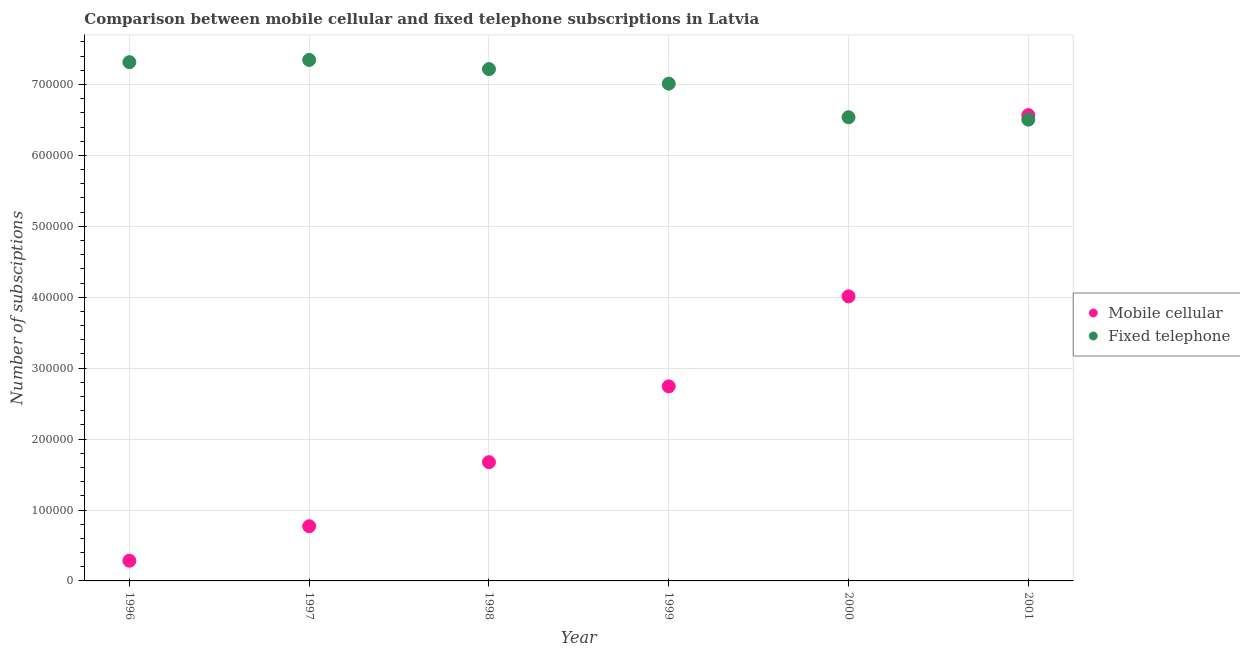What is the number of fixed telephone subscriptions in 1999?
Your response must be concise. 7.01e+05. Across all years, what is the maximum number of mobile cellular subscriptions?
Your response must be concise. 6.57e+05. Across all years, what is the minimum number of mobile cellular subscriptions?
Provide a short and direct response. 2.85e+04. In which year was the number of mobile cellular subscriptions maximum?
Your answer should be very brief. 2001. In which year was the number of mobile cellular subscriptions minimum?
Provide a succinct answer. 1996. What is the total number of fixed telephone subscriptions in the graph?
Your answer should be very brief. 4.19e+06. What is the difference between the number of fixed telephone subscriptions in 1998 and that in 2001?
Your answer should be very brief. 7.13e+04. What is the difference between the number of mobile cellular subscriptions in 1996 and the number of fixed telephone subscriptions in 1998?
Provide a short and direct response. -6.93e+05. What is the average number of fixed telephone subscriptions per year?
Your answer should be very brief. 6.99e+05. In the year 2001, what is the difference between the number of mobile cellular subscriptions and number of fixed telephone subscriptions?
Keep it short and to the point. 6380. What is the ratio of the number of mobile cellular subscriptions in 1996 to that in 1997?
Ensure brevity in your answer.  0.37. What is the difference between the highest and the second highest number of mobile cellular subscriptions?
Provide a short and direct response. 2.56e+05. What is the difference between the highest and the lowest number of mobile cellular subscriptions?
Ensure brevity in your answer.  6.28e+05. In how many years, is the number of mobile cellular subscriptions greater than the average number of mobile cellular subscriptions taken over all years?
Your response must be concise. 3. Is the number of mobile cellular subscriptions strictly less than the number of fixed telephone subscriptions over the years?
Give a very brief answer. No. What is the difference between two consecutive major ticks on the Y-axis?
Provide a succinct answer. 1.00e+05. Are the values on the major ticks of Y-axis written in scientific E-notation?
Offer a terse response. No. Where does the legend appear in the graph?
Offer a terse response. Center right. How many legend labels are there?
Give a very brief answer. 2. What is the title of the graph?
Provide a succinct answer. Comparison between mobile cellular and fixed telephone subscriptions in Latvia. What is the label or title of the Y-axis?
Your answer should be very brief. Number of subsciptions. What is the Number of subsciptions of Mobile cellular in 1996?
Provide a succinct answer. 2.85e+04. What is the Number of subsciptions of Fixed telephone in 1996?
Make the answer very short. 7.32e+05. What is the Number of subsciptions of Mobile cellular in 1997?
Your answer should be compact. 7.71e+04. What is the Number of subsciptions in Fixed telephone in 1997?
Provide a succinct answer. 7.35e+05. What is the Number of subsciptions of Mobile cellular in 1998?
Provide a succinct answer. 1.67e+05. What is the Number of subsciptions of Fixed telephone in 1998?
Offer a terse response. 7.22e+05. What is the Number of subsciptions of Mobile cellular in 1999?
Ensure brevity in your answer.  2.74e+05. What is the Number of subsciptions in Fixed telephone in 1999?
Your answer should be compact. 7.01e+05. What is the Number of subsciptions of Mobile cellular in 2000?
Give a very brief answer. 4.01e+05. What is the Number of subsciptions in Fixed telephone in 2000?
Provide a succinct answer. 6.54e+05. What is the Number of subsciptions of Mobile cellular in 2001?
Keep it short and to the point. 6.57e+05. What is the Number of subsciptions of Fixed telephone in 2001?
Give a very brief answer. 6.50e+05. Across all years, what is the maximum Number of subsciptions in Mobile cellular?
Provide a succinct answer. 6.57e+05. Across all years, what is the maximum Number of subsciptions in Fixed telephone?
Keep it short and to the point. 7.35e+05. Across all years, what is the minimum Number of subsciptions of Mobile cellular?
Your response must be concise. 2.85e+04. Across all years, what is the minimum Number of subsciptions of Fixed telephone?
Your answer should be very brief. 6.50e+05. What is the total Number of subsciptions in Mobile cellular in the graph?
Give a very brief answer. 1.61e+06. What is the total Number of subsciptions in Fixed telephone in the graph?
Provide a succinct answer. 4.19e+06. What is the difference between the Number of subsciptions in Mobile cellular in 1996 and that in 1997?
Offer a very short reply. -4.86e+04. What is the difference between the Number of subsciptions of Fixed telephone in 1996 and that in 1997?
Ensure brevity in your answer.  -3166. What is the difference between the Number of subsciptions of Mobile cellular in 1996 and that in 1998?
Offer a very short reply. -1.39e+05. What is the difference between the Number of subsciptions in Fixed telephone in 1996 and that in 1998?
Your response must be concise. 9775. What is the difference between the Number of subsciptions in Mobile cellular in 1996 and that in 1999?
Your answer should be compact. -2.46e+05. What is the difference between the Number of subsciptions of Fixed telephone in 1996 and that in 1999?
Provide a short and direct response. 3.03e+04. What is the difference between the Number of subsciptions in Mobile cellular in 1996 and that in 2000?
Ensure brevity in your answer.  -3.73e+05. What is the difference between the Number of subsciptions in Fixed telephone in 1996 and that in 2000?
Your answer should be very brief. 7.77e+04. What is the difference between the Number of subsciptions of Mobile cellular in 1996 and that in 2001?
Give a very brief answer. -6.28e+05. What is the difference between the Number of subsciptions in Fixed telephone in 1996 and that in 2001?
Your answer should be very brief. 8.11e+04. What is the difference between the Number of subsciptions of Mobile cellular in 1997 and that in 1998?
Provide a succinct answer. -9.04e+04. What is the difference between the Number of subsciptions in Fixed telephone in 1997 and that in 1998?
Make the answer very short. 1.29e+04. What is the difference between the Number of subsciptions in Mobile cellular in 1997 and that in 1999?
Ensure brevity in your answer.  -1.97e+05. What is the difference between the Number of subsciptions of Fixed telephone in 1997 and that in 1999?
Keep it short and to the point. 3.35e+04. What is the difference between the Number of subsciptions of Mobile cellular in 1997 and that in 2000?
Offer a terse response. -3.24e+05. What is the difference between the Number of subsciptions of Fixed telephone in 1997 and that in 2000?
Offer a very short reply. 8.08e+04. What is the difference between the Number of subsciptions of Mobile cellular in 1997 and that in 2001?
Offer a very short reply. -5.80e+05. What is the difference between the Number of subsciptions of Fixed telephone in 1997 and that in 2001?
Provide a succinct answer. 8.42e+04. What is the difference between the Number of subsciptions of Mobile cellular in 1998 and that in 1999?
Give a very brief answer. -1.07e+05. What is the difference between the Number of subsciptions in Fixed telephone in 1998 and that in 1999?
Keep it short and to the point. 2.05e+04. What is the difference between the Number of subsciptions in Mobile cellular in 1998 and that in 2000?
Your answer should be very brief. -2.34e+05. What is the difference between the Number of subsciptions in Fixed telephone in 1998 and that in 2000?
Your answer should be very brief. 6.79e+04. What is the difference between the Number of subsciptions of Mobile cellular in 1998 and that in 2001?
Your response must be concise. -4.89e+05. What is the difference between the Number of subsciptions of Fixed telephone in 1998 and that in 2001?
Keep it short and to the point. 7.13e+04. What is the difference between the Number of subsciptions in Mobile cellular in 1999 and that in 2000?
Ensure brevity in your answer.  -1.27e+05. What is the difference between the Number of subsciptions in Fixed telephone in 1999 and that in 2000?
Provide a succinct answer. 4.74e+04. What is the difference between the Number of subsciptions in Mobile cellular in 1999 and that in 2001?
Your answer should be compact. -3.82e+05. What is the difference between the Number of subsciptions of Fixed telephone in 1999 and that in 2001?
Provide a succinct answer. 5.08e+04. What is the difference between the Number of subsciptions in Mobile cellular in 2000 and that in 2001?
Your answer should be compact. -2.56e+05. What is the difference between the Number of subsciptions of Fixed telephone in 2000 and that in 2001?
Give a very brief answer. 3398. What is the difference between the Number of subsciptions in Mobile cellular in 1996 and the Number of subsciptions in Fixed telephone in 1997?
Provide a succinct answer. -7.06e+05. What is the difference between the Number of subsciptions in Mobile cellular in 1996 and the Number of subsciptions in Fixed telephone in 1998?
Give a very brief answer. -6.93e+05. What is the difference between the Number of subsciptions of Mobile cellular in 1996 and the Number of subsciptions of Fixed telephone in 1999?
Keep it short and to the point. -6.73e+05. What is the difference between the Number of subsciptions in Mobile cellular in 1996 and the Number of subsciptions in Fixed telephone in 2000?
Make the answer very short. -6.25e+05. What is the difference between the Number of subsciptions in Mobile cellular in 1996 and the Number of subsciptions in Fixed telephone in 2001?
Provide a succinct answer. -6.22e+05. What is the difference between the Number of subsciptions in Mobile cellular in 1997 and the Number of subsciptions in Fixed telephone in 1998?
Keep it short and to the point. -6.45e+05. What is the difference between the Number of subsciptions in Mobile cellular in 1997 and the Number of subsciptions in Fixed telephone in 1999?
Provide a short and direct response. -6.24e+05. What is the difference between the Number of subsciptions of Mobile cellular in 1997 and the Number of subsciptions of Fixed telephone in 2000?
Make the answer very short. -5.77e+05. What is the difference between the Number of subsciptions of Mobile cellular in 1997 and the Number of subsciptions of Fixed telephone in 2001?
Make the answer very short. -5.73e+05. What is the difference between the Number of subsciptions in Mobile cellular in 1998 and the Number of subsciptions in Fixed telephone in 1999?
Ensure brevity in your answer.  -5.34e+05. What is the difference between the Number of subsciptions of Mobile cellular in 1998 and the Number of subsciptions of Fixed telephone in 2000?
Your answer should be compact. -4.86e+05. What is the difference between the Number of subsciptions of Mobile cellular in 1998 and the Number of subsciptions of Fixed telephone in 2001?
Ensure brevity in your answer.  -4.83e+05. What is the difference between the Number of subsciptions in Mobile cellular in 1999 and the Number of subsciptions in Fixed telephone in 2000?
Provide a short and direct response. -3.80e+05. What is the difference between the Number of subsciptions of Mobile cellular in 1999 and the Number of subsciptions of Fixed telephone in 2001?
Ensure brevity in your answer.  -3.76e+05. What is the difference between the Number of subsciptions in Mobile cellular in 2000 and the Number of subsciptions in Fixed telephone in 2001?
Ensure brevity in your answer.  -2.49e+05. What is the average Number of subsciptions of Mobile cellular per year?
Your answer should be very brief. 2.68e+05. What is the average Number of subsciptions in Fixed telephone per year?
Your response must be concise. 6.99e+05. In the year 1996, what is the difference between the Number of subsciptions in Mobile cellular and Number of subsciptions in Fixed telephone?
Provide a succinct answer. -7.03e+05. In the year 1997, what is the difference between the Number of subsciptions in Mobile cellular and Number of subsciptions in Fixed telephone?
Your response must be concise. -6.58e+05. In the year 1998, what is the difference between the Number of subsciptions in Mobile cellular and Number of subsciptions in Fixed telephone?
Ensure brevity in your answer.  -5.54e+05. In the year 1999, what is the difference between the Number of subsciptions in Mobile cellular and Number of subsciptions in Fixed telephone?
Keep it short and to the point. -4.27e+05. In the year 2000, what is the difference between the Number of subsciptions in Mobile cellular and Number of subsciptions in Fixed telephone?
Offer a terse response. -2.53e+05. In the year 2001, what is the difference between the Number of subsciptions of Mobile cellular and Number of subsciptions of Fixed telephone?
Offer a terse response. 6380. What is the ratio of the Number of subsciptions in Mobile cellular in 1996 to that in 1997?
Your answer should be very brief. 0.37. What is the ratio of the Number of subsciptions in Fixed telephone in 1996 to that in 1997?
Give a very brief answer. 1. What is the ratio of the Number of subsciptions of Mobile cellular in 1996 to that in 1998?
Give a very brief answer. 0.17. What is the ratio of the Number of subsciptions of Fixed telephone in 1996 to that in 1998?
Your answer should be very brief. 1.01. What is the ratio of the Number of subsciptions of Mobile cellular in 1996 to that in 1999?
Provide a short and direct response. 0.1. What is the ratio of the Number of subsciptions of Fixed telephone in 1996 to that in 1999?
Your answer should be very brief. 1.04. What is the ratio of the Number of subsciptions of Mobile cellular in 1996 to that in 2000?
Ensure brevity in your answer.  0.07. What is the ratio of the Number of subsciptions in Fixed telephone in 1996 to that in 2000?
Offer a terse response. 1.12. What is the ratio of the Number of subsciptions in Mobile cellular in 1996 to that in 2001?
Your response must be concise. 0.04. What is the ratio of the Number of subsciptions of Fixed telephone in 1996 to that in 2001?
Offer a very short reply. 1.12. What is the ratio of the Number of subsciptions of Mobile cellular in 1997 to that in 1998?
Your answer should be compact. 0.46. What is the ratio of the Number of subsciptions in Fixed telephone in 1997 to that in 1998?
Offer a very short reply. 1.02. What is the ratio of the Number of subsciptions in Mobile cellular in 1997 to that in 1999?
Ensure brevity in your answer.  0.28. What is the ratio of the Number of subsciptions in Fixed telephone in 1997 to that in 1999?
Offer a terse response. 1.05. What is the ratio of the Number of subsciptions of Mobile cellular in 1997 to that in 2000?
Make the answer very short. 0.19. What is the ratio of the Number of subsciptions of Fixed telephone in 1997 to that in 2000?
Your answer should be compact. 1.12. What is the ratio of the Number of subsciptions in Mobile cellular in 1997 to that in 2001?
Your answer should be very brief. 0.12. What is the ratio of the Number of subsciptions of Fixed telephone in 1997 to that in 2001?
Offer a terse response. 1.13. What is the ratio of the Number of subsciptions in Mobile cellular in 1998 to that in 1999?
Your response must be concise. 0.61. What is the ratio of the Number of subsciptions of Fixed telephone in 1998 to that in 1999?
Your response must be concise. 1.03. What is the ratio of the Number of subsciptions of Mobile cellular in 1998 to that in 2000?
Keep it short and to the point. 0.42. What is the ratio of the Number of subsciptions in Fixed telephone in 1998 to that in 2000?
Make the answer very short. 1.1. What is the ratio of the Number of subsciptions of Mobile cellular in 1998 to that in 2001?
Offer a terse response. 0.25. What is the ratio of the Number of subsciptions of Fixed telephone in 1998 to that in 2001?
Provide a short and direct response. 1.11. What is the ratio of the Number of subsciptions of Mobile cellular in 1999 to that in 2000?
Provide a succinct answer. 0.68. What is the ratio of the Number of subsciptions in Fixed telephone in 1999 to that in 2000?
Provide a short and direct response. 1.07. What is the ratio of the Number of subsciptions in Mobile cellular in 1999 to that in 2001?
Provide a succinct answer. 0.42. What is the ratio of the Number of subsciptions of Fixed telephone in 1999 to that in 2001?
Give a very brief answer. 1.08. What is the ratio of the Number of subsciptions in Mobile cellular in 2000 to that in 2001?
Provide a short and direct response. 0.61. What is the difference between the highest and the second highest Number of subsciptions in Mobile cellular?
Give a very brief answer. 2.56e+05. What is the difference between the highest and the second highest Number of subsciptions in Fixed telephone?
Make the answer very short. 3166. What is the difference between the highest and the lowest Number of subsciptions of Mobile cellular?
Offer a very short reply. 6.28e+05. What is the difference between the highest and the lowest Number of subsciptions of Fixed telephone?
Your answer should be compact. 8.42e+04. 